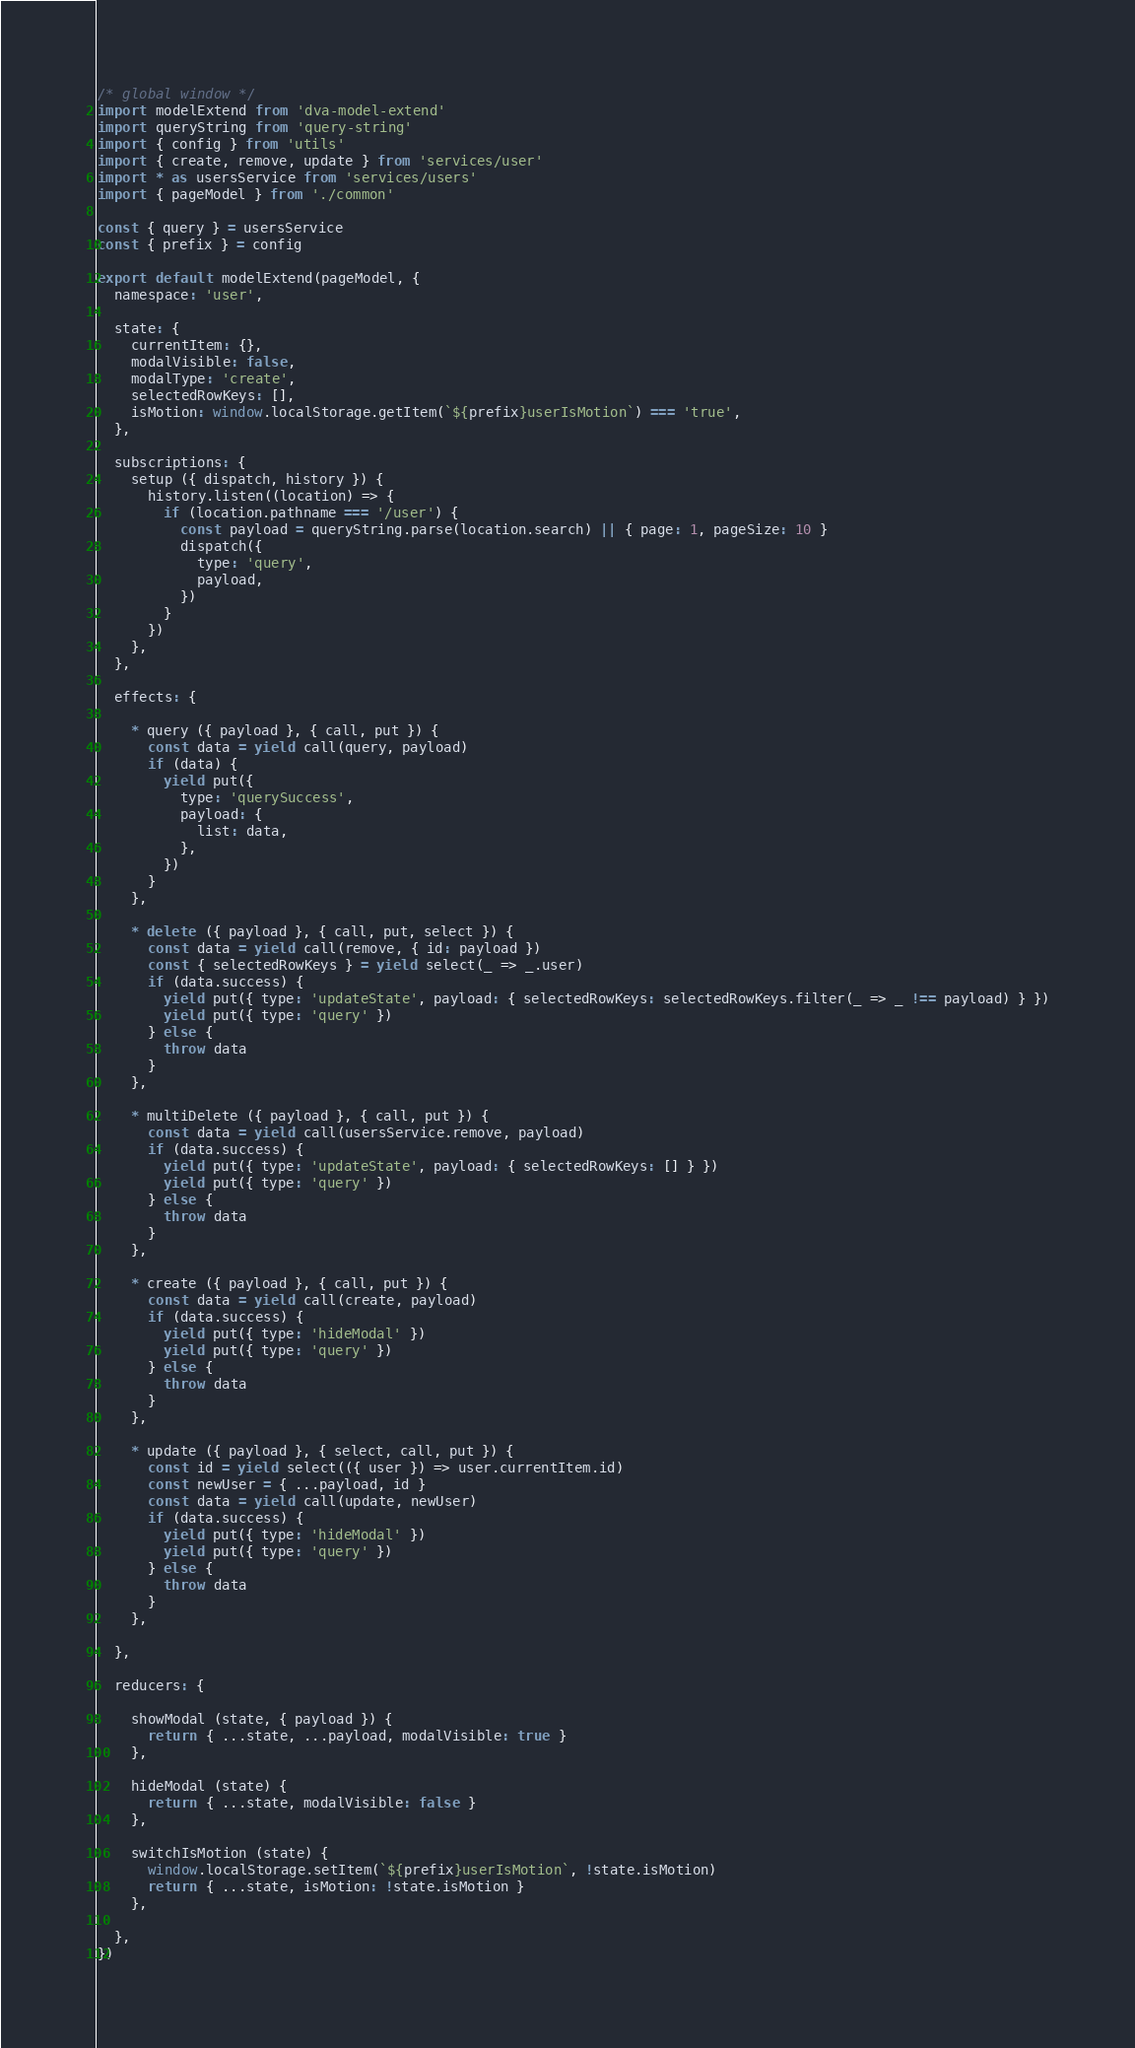<code> <loc_0><loc_0><loc_500><loc_500><_JavaScript_>/* global window */
import modelExtend from 'dva-model-extend'
import queryString from 'query-string'
import { config } from 'utils'
import { create, remove, update } from 'services/user'
import * as usersService from 'services/users'
import { pageModel } from './common'

const { query } = usersService
const { prefix } = config

export default modelExtend(pageModel, {
  namespace: 'user',

  state: {
    currentItem: {},
    modalVisible: false,
    modalType: 'create',
    selectedRowKeys: [],
    isMotion: window.localStorage.getItem(`${prefix}userIsMotion`) === 'true',
  },

  subscriptions: {
    setup ({ dispatch, history }) {
      history.listen((location) => {
        if (location.pathname === '/user') {
          const payload = queryString.parse(location.search) || { page: 1, pageSize: 10 }
          dispatch({
            type: 'query',
            payload,
          })
        }
      })
    },
  },

  effects: {

    * query ({ payload }, { call, put }) {
      const data = yield call(query, payload)
      if (data) {
        yield put({
          type: 'querySuccess',
          payload: {
            list: data,
          },
        })
      }
    },

    * delete ({ payload }, { call, put, select }) {
      const data = yield call(remove, { id: payload })
      const { selectedRowKeys } = yield select(_ => _.user)
      if (data.success) {
        yield put({ type: 'updateState', payload: { selectedRowKeys: selectedRowKeys.filter(_ => _ !== payload) } })
        yield put({ type: 'query' })
      } else {
        throw data
      }
    },

    * multiDelete ({ payload }, { call, put }) {
      const data = yield call(usersService.remove, payload)
      if (data.success) {
        yield put({ type: 'updateState', payload: { selectedRowKeys: [] } })
        yield put({ type: 'query' })
      } else {
        throw data
      }
    },

    * create ({ payload }, { call, put }) {
      const data = yield call(create, payload)
      if (data.success) {
        yield put({ type: 'hideModal' })
        yield put({ type: 'query' })
      } else {
        throw data
      }
    },

    * update ({ payload }, { select, call, put }) {
      const id = yield select(({ user }) => user.currentItem.id)
      const newUser = { ...payload, id }
      const data = yield call(update, newUser)
      if (data.success) {
        yield put({ type: 'hideModal' })
        yield put({ type: 'query' })
      } else {
        throw data
      }
    },

  },

  reducers: {

    showModal (state, { payload }) {
      return { ...state, ...payload, modalVisible: true }
    },

    hideModal (state) {
      return { ...state, modalVisible: false }
    },

    switchIsMotion (state) {
      window.localStorage.setItem(`${prefix}userIsMotion`, !state.isMotion)
      return { ...state, isMotion: !state.isMotion }
    },

  },
})
</code> 